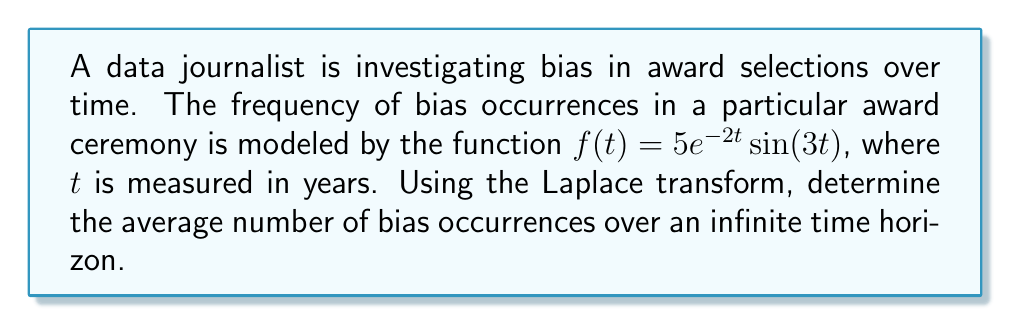Show me your answer to this math problem. To solve this problem, we'll follow these steps:

1) First, recall that the Laplace transform of $f(t)$ is defined as:

   $$F(s) = \int_0^\infty f(t)e^{-st}dt$$

2) We need to find the Laplace transform of $f(t) = 5e^{-2t}\sin(3t)$. This is a standard form, and its Laplace transform is:

   $$F(s) = \frac{5 \cdot 3}{(s+2)^2 + 3^2} = \frac{15}{(s+2)^2 + 9}$$

3) To find the average number of bias occurrences over an infinite time horizon, we need to use the Final Value Theorem. This theorem states that:

   $$\lim_{t \to \infty} f(t) = \lim_{s \to 0} sF(s)$$

4) Let's apply this theorem:

   $$\lim_{s \to 0} sF(s) = \lim_{s \to 0} s \cdot \frac{15}{(s+2)^2 + 9}$$

5) Simplify:

   $$= \lim_{s \to 0} \frac{15s}{s^2 + 4s + 13}$$

6) As $s$ approaches 0, this limit becomes:

   $$= \frac{15 \cdot 0}{0^2 + 4 \cdot 0 + 13} = \frac{0}{13} = 0$$

Therefore, the average number of bias occurrences over an infinite time horizon is 0.
Answer: 0 